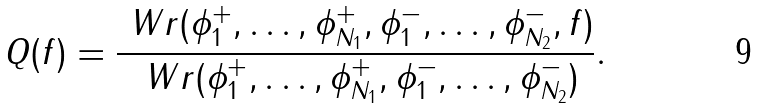<formula> <loc_0><loc_0><loc_500><loc_500>Q ( f ) = \frac { \ W r ( \phi ^ { + } _ { 1 } , \dots , \phi ^ { + } _ { N _ { 1 } } , \phi ^ { - } _ { 1 } , \dots , \phi ^ { - } _ { N _ { 2 } } , f ) } { \ W r ( \phi ^ { + } _ { 1 } , \dots , \phi ^ { + } _ { N _ { 1 } } , \phi ^ { - } _ { 1 } , \dots , \phi ^ { - } _ { N _ { 2 } } ) } .</formula> 